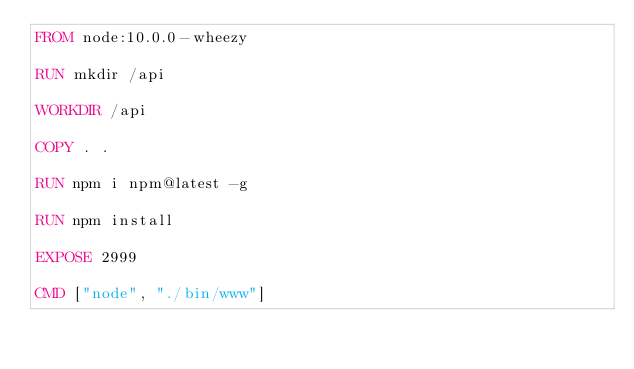<code> <loc_0><loc_0><loc_500><loc_500><_Dockerfile_>FROM node:10.0.0-wheezy

RUN mkdir /api

WORKDIR /api

COPY . .

RUN npm i npm@latest -g

RUN npm install

EXPOSE 2999

CMD ["node", "./bin/www"]</code> 